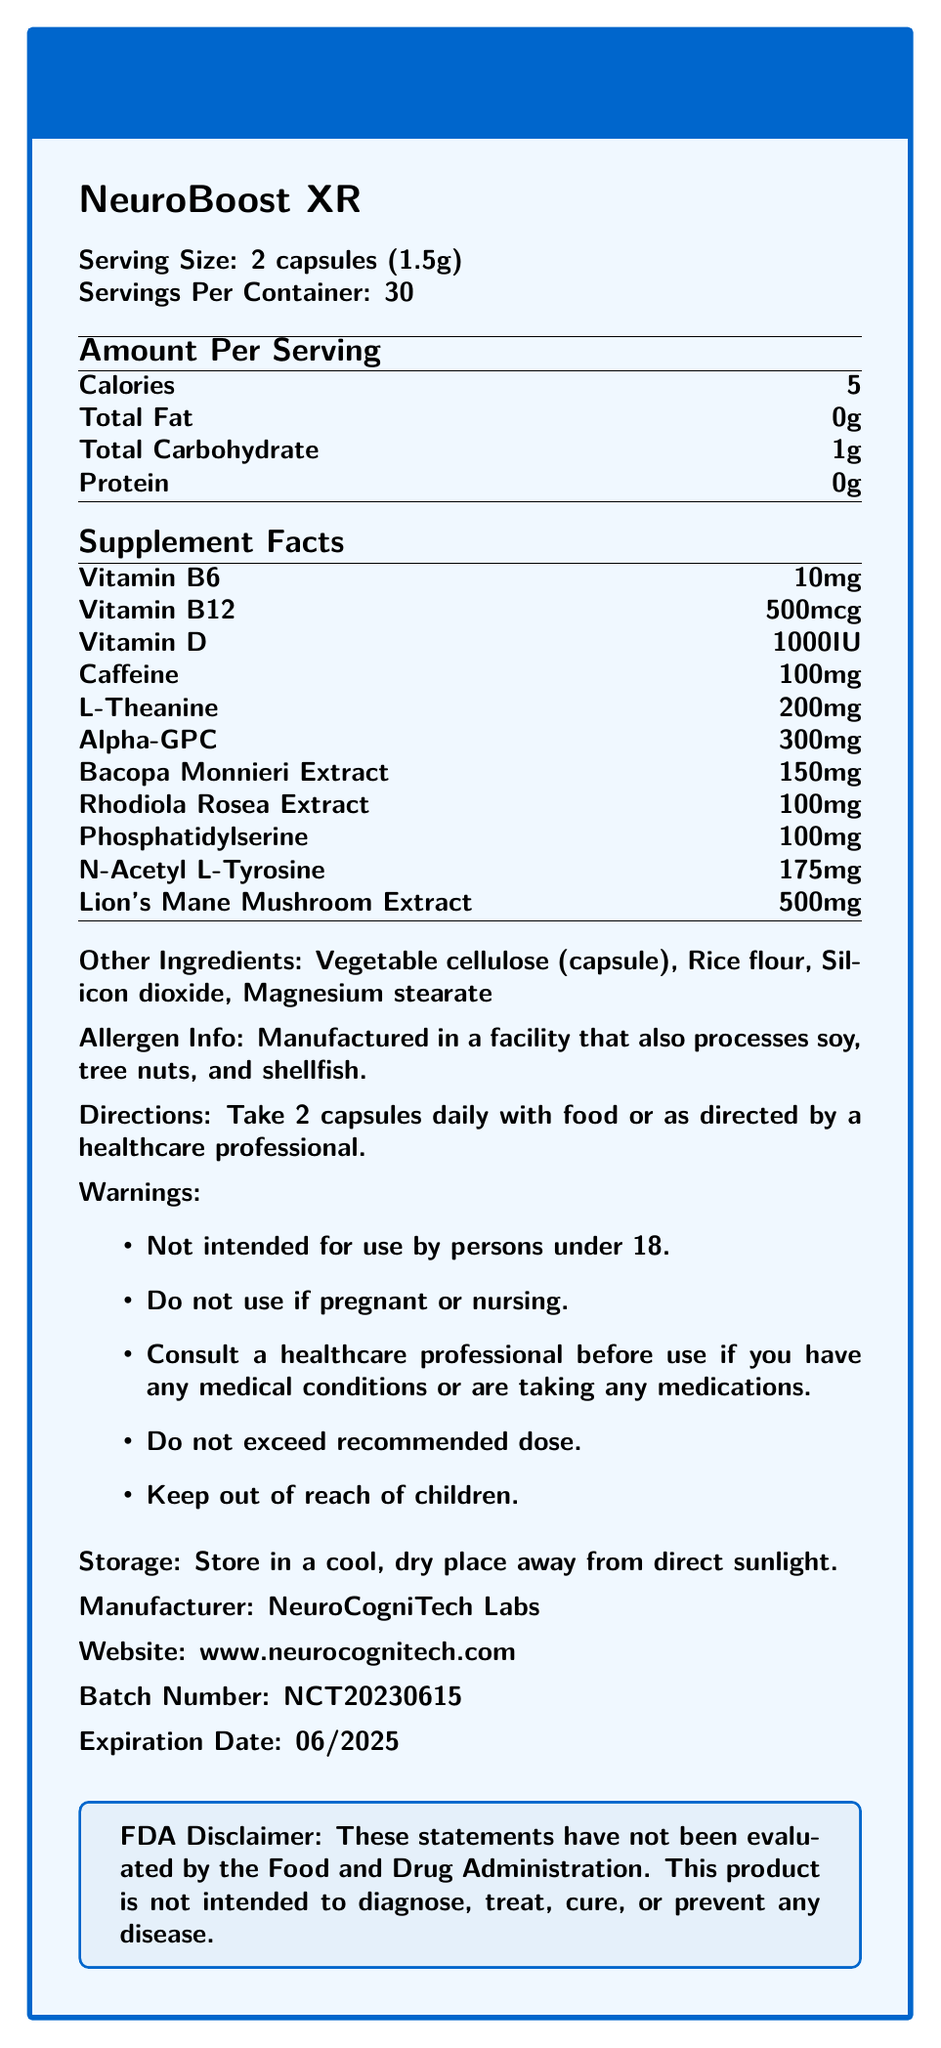what is the serving size of NeuroBoost XR? The document specifies that the serving size is 2 capsules weighing a total of 1.5 grams.
Answer: 2 capsules (1.5g) how many servings are in each container? The document states that there are 30 servings per container.
Answer: 30 what is the amount of caffeine per serving? According to the Supplement Facts section, each serving contains 100mg of caffeine.
Answer: 100mg how many calories are in a serving? The Amount Per Serving section lists the calorie content as 5 per serving.
Answer: 5 what is the dosage recommendation for NeuroBoost XR? The Directions section advises taking 2 capsules daily with food or as directed by a healthcare professional.
Answer: Take 2 capsules daily with food or as directed by a healthcare professional. which vitamin is present in the highest quantity per serving? A. Vitamin B6 B. Vitamin B12 C. Vitamin D D. Vitamin C The Supplement Facts section shows that Vitamin D is present at 1000IU, which is higher than the amounts of Vitamins B6 and B12.
Answer: C. Vitamin D what is the warning for pregnant or nursing women? The Warnings section specifically states that pregnant or nursing women should not use the product.
Answer: Do not use if pregnant or nursing. what is the form of Lion's Mane Mushroom used in the supplement? A. Powder B. Extract C. Whole Mushroom The Supplement Facts section specifies it as Lion's Mane Mushroom Extract, indicating it is in an extract form.
Answer: B. Extract is the product safe for children under 18 years old? The Warnings section clearly states that the product is not intended for use by persons under 18.
Answer: No describe the main idea of the document. The document provides comprehensive information about the nootropic supplement NeuroBoost XR, including its nutritional composition, ingredient list, recommended dosage, warnings, and storage guidelines, along with manufacturer details.
Answer: The document is a Nutrition Facts Label for a nootropic supplement called NeuroBoost XR, which provides details about serving size, number of servings per container, nutrient content, ingredients, and usage instructions. It also includes warnings, storage information, and manufacturing details. what is the batch number of the product? The Batch Number section indicates the batch number as NCT20230615.
Answer: NCT20230615 how much L-Theanine does each serving contain? The Supplement Facts section lists the L-Theanine content as 200mg per serving.
Answer: 200mg are there any potential allergens listed? The Allergen Info section states that the product is manufactured in a facility that also processes soy, tree nuts, and shellfish.
Answer: Yes is there an FDA disclaimer in the document? The document includes an FDA disclaimer stating that the statements have not been evaluated by the Food and Drug Administration and that the product is not intended to diagnose, treat, cure, or prevent any disease.
Answer: Yes what are the other ingredients in NeuroBoost XR? The Other Ingredients section lists these components.
Answer: Vegetable cellulose (capsule), Rice flour, Silicon dioxide, Magnesium stearate when does the product expire? The Expiration Date section specifies the expiration date as 06/2025.
Answer: 06/2025 how much Phosphatidylserine is present in each serving? A. 75mg B. 100mg C. 125mg D. 150mg The Supplement Facts section lists Phosphatidylserine content as 100mg per serving.
Answer: B. 100mg what is the URL for the manufacturer's website? The document provides the website as www.neurocognitech.com in the Manufacturer section.
Answer: www.neurocognitech.com what is the caffeine source in NeuroBoost XR? The document lists the amount of caffeine per serving but does not specify the source of the caffeine.
Answer: Cannot be determined 